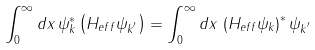Convert formula to latex. <formula><loc_0><loc_0><loc_500><loc_500>\int _ { 0 } ^ { \infty } d x \, \psi _ { k } ^ { * } \left ( H _ { e f f } \psi _ { k ^ { ^ { \prime } } } \right ) = \int _ { 0 } ^ { \infty } d x \, \left ( H _ { e f f } \psi _ { k } \right ) ^ { * } \psi _ { k ^ { ^ { \prime } } }</formula> 